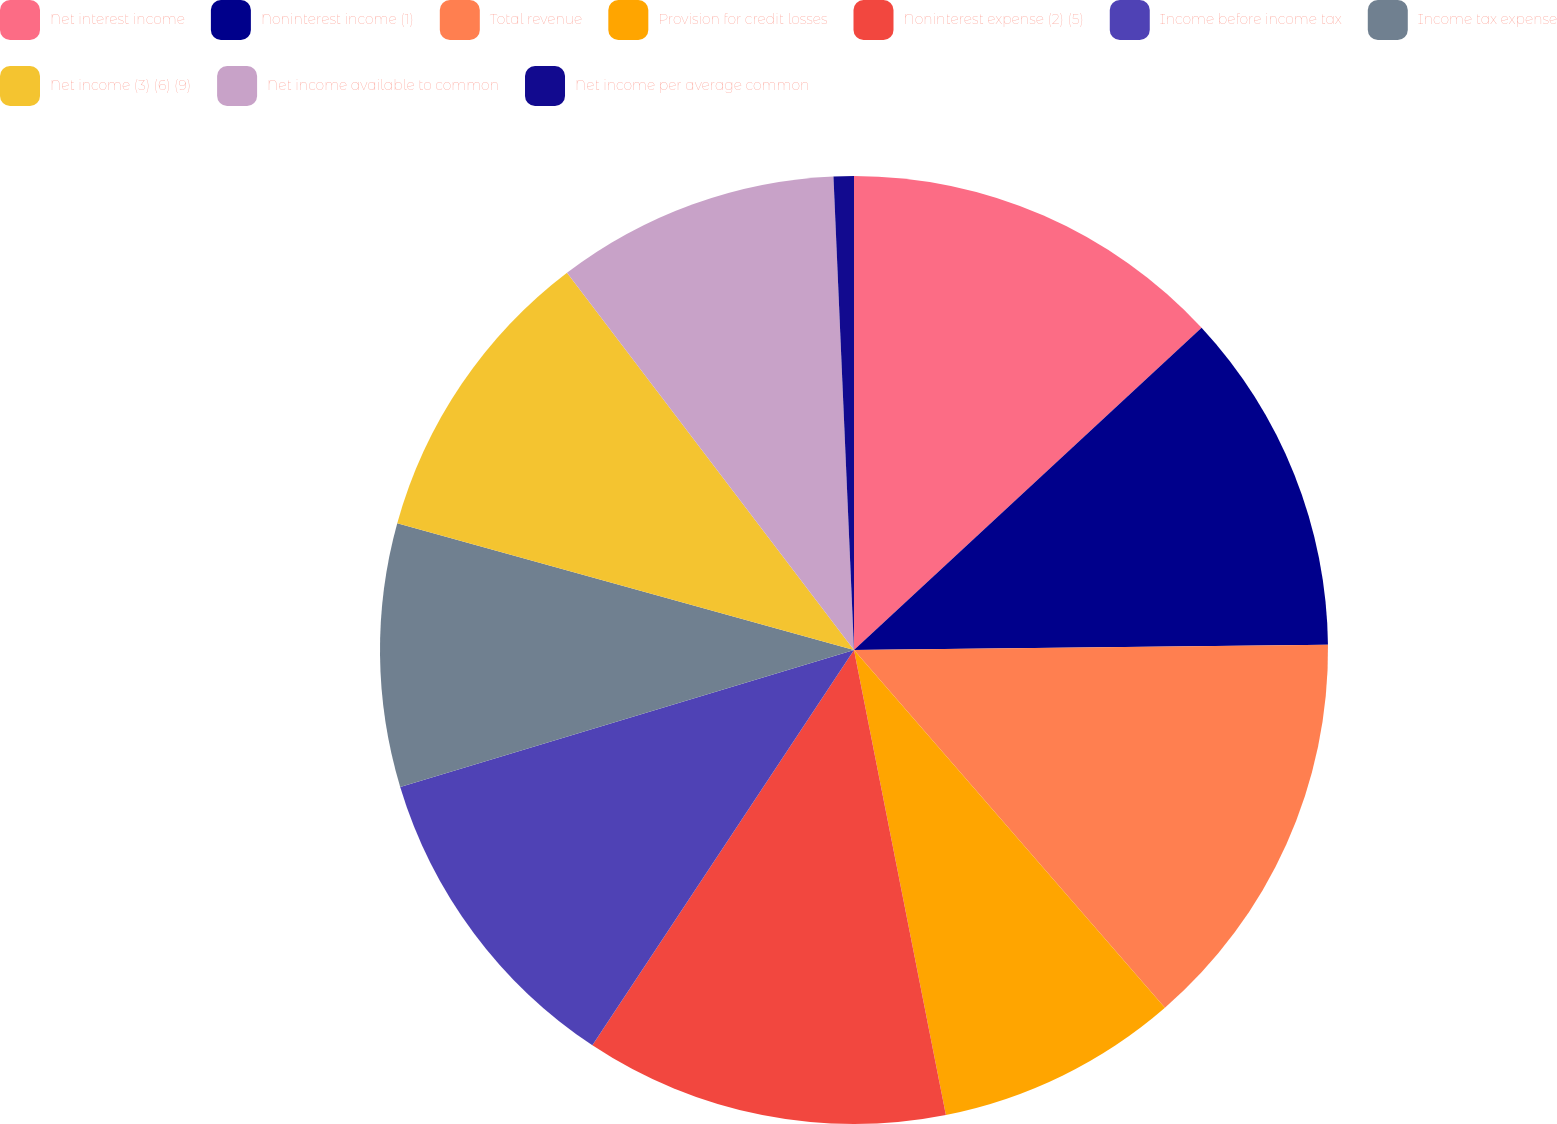Convert chart to OTSL. <chart><loc_0><loc_0><loc_500><loc_500><pie_chart><fcel>Net interest income<fcel>Noninterest income (1)<fcel>Total revenue<fcel>Provision for credit losses<fcel>Noninterest expense (2) (5)<fcel>Income before income tax<fcel>Income tax expense<fcel>Net income (3) (6) (9)<fcel>Net income available to common<fcel>Net income per average common<nl><fcel>13.1%<fcel>11.72%<fcel>13.79%<fcel>8.28%<fcel>12.41%<fcel>11.03%<fcel>8.97%<fcel>10.34%<fcel>9.66%<fcel>0.69%<nl></chart> 